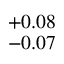<formula> <loc_0><loc_0><loc_500><loc_500>^ { + 0 . 0 8 } _ { - 0 . 0 7 }</formula> 